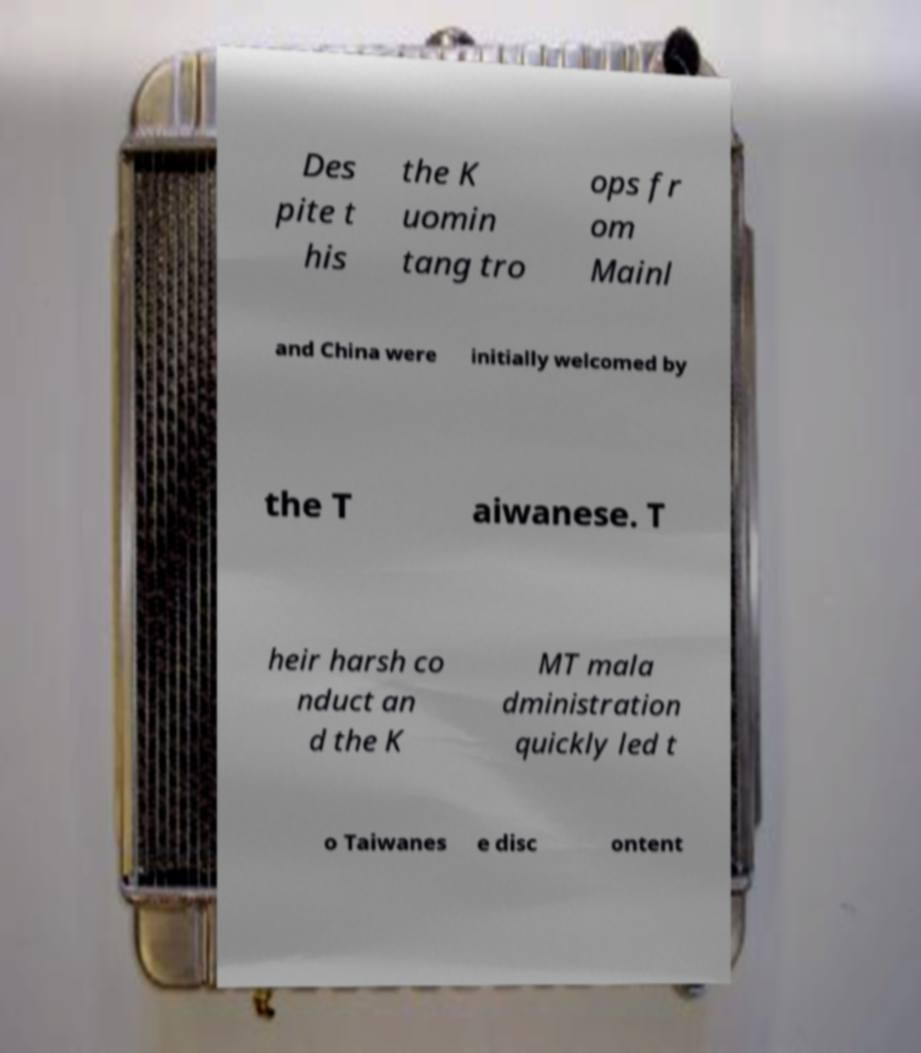Could you assist in decoding the text presented in this image and type it out clearly? Des pite t his the K uomin tang tro ops fr om Mainl and China were initially welcomed by the T aiwanese. T heir harsh co nduct an d the K MT mala dministration quickly led t o Taiwanes e disc ontent 